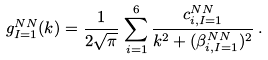Convert formula to latex. <formula><loc_0><loc_0><loc_500><loc_500>g _ { I = 1 } ^ { N N } ( k ) = \frac { 1 } { 2 \sqrt { \pi } } \, \sum _ { i = 1 } ^ { 6 } \frac { c _ { i , I = 1 } ^ { N N } } { k ^ { 2 } + ( \beta _ { i , I = 1 } ^ { N N } ) ^ { 2 } } \, .</formula> 